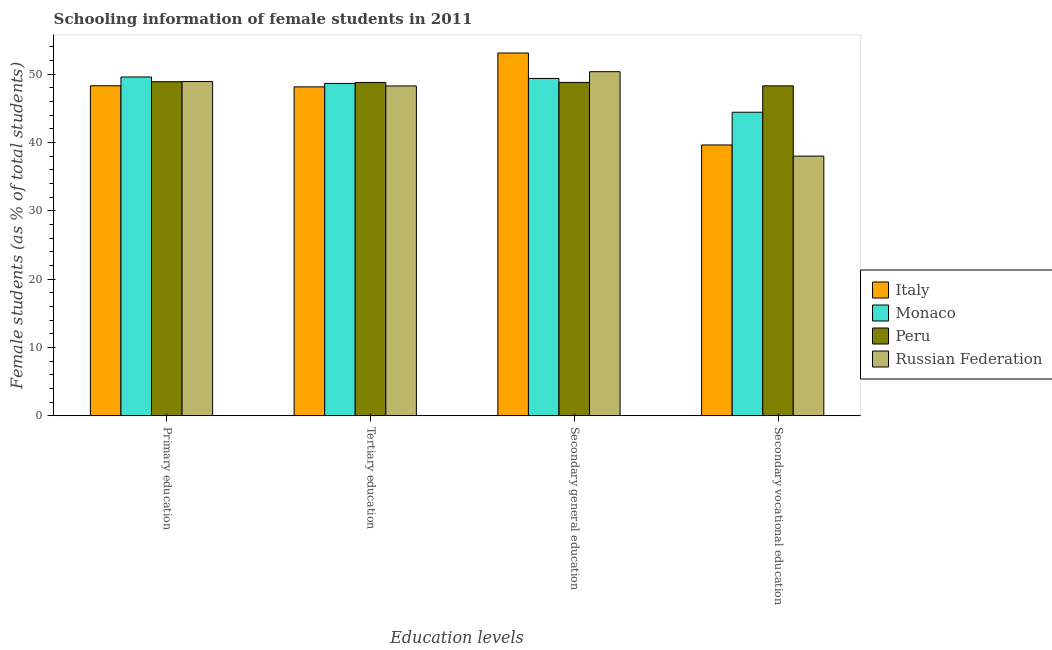How many groups of bars are there?
Provide a short and direct response. 4. Are the number of bars on each tick of the X-axis equal?
Provide a short and direct response. Yes. How many bars are there on the 2nd tick from the right?
Keep it short and to the point. 4. What is the label of the 2nd group of bars from the left?
Your answer should be compact. Tertiary education. What is the percentage of female students in primary education in Italy?
Offer a terse response. 48.32. Across all countries, what is the maximum percentage of female students in secondary vocational education?
Provide a short and direct response. 48.3. Across all countries, what is the minimum percentage of female students in secondary education?
Your answer should be very brief. 48.81. In which country was the percentage of female students in secondary vocational education minimum?
Your answer should be compact. Russian Federation. What is the total percentage of female students in secondary education in the graph?
Keep it short and to the point. 201.68. What is the difference between the percentage of female students in tertiary education in Russian Federation and that in Italy?
Offer a terse response. 0.14. What is the difference between the percentage of female students in tertiary education in Russian Federation and the percentage of female students in secondary vocational education in Monaco?
Provide a short and direct response. 3.84. What is the average percentage of female students in secondary vocational education per country?
Your answer should be very brief. 42.61. What is the difference between the percentage of female students in primary education and percentage of female students in secondary vocational education in Peru?
Your answer should be very brief. 0.61. In how many countries, is the percentage of female students in secondary education greater than 12 %?
Your response must be concise. 4. What is the ratio of the percentage of female students in secondary vocational education in Peru to that in Russian Federation?
Ensure brevity in your answer.  1.27. Is the difference between the percentage of female students in secondary education in Russian Federation and Monaco greater than the difference between the percentage of female students in secondary vocational education in Russian Federation and Monaco?
Offer a very short reply. Yes. What is the difference between the highest and the second highest percentage of female students in secondary vocational education?
Keep it short and to the point. 3.86. What is the difference between the highest and the lowest percentage of female students in secondary education?
Your response must be concise. 4.3. In how many countries, is the percentage of female students in secondary education greater than the average percentage of female students in secondary education taken over all countries?
Provide a succinct answer. 1. Is the sum of the percentage of female students in primary education in Russian Federation and Peru greater than the maximum percentage of female students in secondary vocational education across all countries?
Ensure brevity in your answer.  Yes. What does the 1st bar from the left in Secondary vocational education represents?
Offer a terse response. Italy. What does the 2nd bar from the right in Primary education represents?
Your answer should be very brief. Peru. How many bars are there?
Make the answer very short. 16. Does the graph contain any zero values?
Your answer should be very brief. No. Does the graph contain grids?
Offer a very short reply. No. How are the legend labels stacked?
Offer a terse response. Vertical. What is the title of the graph?
Make the answer very short. Schooling information of female students in 2011. Does "Pacific island small states" appear as one of the legend labels in the graph?
Make the answer very short. No. What is the label or title of the X-axis?
Ensure brevity in your answer.  Education levels. What is the label or title of the Y-axis?
Make the answer very short. Female students (as % of total students). What is the Female students (as % of total students) in Italy in Primary education?
Provide a succinct answer. 48.32. What is the Female students (as % of total students) of Monaco in Primary education?
Your answer should be compact. 49.6. What is the Female students (as % of total students) in Peru in Primary education?
Provide a succinct answer. 48.91. What is the Female students (as % of total students) in Russian Federation in Primary education?
Keep it short and to the point. 48.94. What is the Female students (as % of total students) in Italy in Tertiary education?
Your answer should be very brief. 48.15. What is the Female students (as % of total students) in Monaco in Tertiary education?
Provide a succinct answer. 48.66. What is the Female students (as % of total students) in Peru in Tertiary education?
Your answer should be very brief. 48.8. What is the Female students (as % of total students) in Russian Federation in Tertiary education?
Provide a succinct answer. 48.29. What is the Female students (as % of total students) of Italy in Secondary general education?
Offer a very short reply. 53.11. What is the Female students (as % of total students) in Monaco in Secondary general education?
Your answer should be very brief. 49.39. What is the Female students (as % of total students) of Peru in Secondary general education?
Ensure brevity in your answer.  48.81. What is the Female students (as % of total students) in Russian Federation in Secondary general education?
Your response must be concise. 50.38. What is the Female students (as % of total students) in Italy in Secondary vocational education?
Provide a succinct answer. 39.65. What is the Female students (as % of total students) in Monaco in Secondary vocational education?
Offer a very short reply. 44.44. What is the Female students (as % of total students) in Peru in Secondary vocational education?
Offer a terse response. 48.3. What is the Female students (as % of total students) in Russian Federation in Secondary vocational education?
Your answer should be very brief. 38.02. Across all Education levels, what is the maximum Female students (as % of total students) in Italy?
Your response must be concise. 53.11. Across all Education levels, what is the maximum Female students (as % of total students) of Monaco?
Provide a short and direct response. 49.6. Across all Education levels, what is the maximum Female students (as % of total students) of Peru?
Ensure brevity in your answer.  48.91. Across all Education levels, what is the maximum Female students (as % of total students) in Russian Federation?
Your answer should be very brief. 50.38. Across all Education levels, what is the minimum Female students (as % of total students) in Italy?
Your answer should be compact. 39.65. Across all Education levels, what is the minimum Female students (as % of total students) of Monaco?
Ensure brevity in your answer.  44.44. Across all Education levels, what is the minimum Female students (as % of total students) in Peru?
Make the answer very short. 48.3. Across all Education levels, what is the minimum Female students (as % of total students) of Russian Federation?
Keep it short and to the point. 38.02. What is the total Female students (as % of total students) of Italy in the graph?
Provide a succinct answer. 189.24. What is the total Female students (as % of total students) of Monaco in the graph?
Give a very brief answer. 192.09. What is the total Female students (as % of total students) of Peru in the graph?
Offer a very short reply. 194.83. What is the total Female students (as % of total students) in Russian Federation in the graph?
Offer a very short reply. 185.62. What is the difference between the Female students (as % of total students) in Italy in Primary education and that in Tertiary education?
Provide a succinct answer. 0.17. What is the difference between the Female students (as % of total students) of Monaco in Primary education and that in Tertiary education?
Make the answer very short. 0.94. What is the difference between the Female students (as % of total students) in Peru in Primary education and that in Tertiary education?
Provide a succinct answer. 0.11. What is the difference between the Female students (as % of total students) in Russian Federation in Primary education and that in Tertiary education?
Provide a succinct answer. 0.65. What is the difference between the Female students (as % of total students) of Italy in Primary education and that in Secondary general education?
Give a very brief answer. -4.79. What is the difference between the Female students (as % of total students) in Monaco in Primary education and that in Secondary general education?
Provide a short and direct response. 0.22. What is the difference between the Female students (as % of total students) in Peru in Primary education and that in Secondary general education?
Provide a short and direct response. 0.1. What is the difference between the Female students (as % of total students) of Russian Federation in Primary education and that in Secondary general education?
Provide a succinct answer. -1.44. What is the difference between the Female students (as % of total students) in Italy in Primary education and that in Secondary vocational education?
Your answer should be compact. 8.67. What is the difference between the Female students (as % of total students) in Monaco in Primary education and that in Secondary vocational education?
Provide a succinct answer. 5.16. What is the difference between the Female students (as % of total students) of Peru in Primary education and that in Secondary vocational education?
Your answer should be very brief. 0.61. What is the difference between the Female students (as % of total students) of Russian Federation in Primary education and that in Secondary vocational education?
Give a very brief answer. 10.92. What is the difference between the Female students (as % of total students) of Italy in Tertiary education and that in Secondary general education?
Your response must be concise. -4.96. What is the difference between the Female students (as % of total students) of Monaco in Tertiary education and that in Secondary general education?
Provide a succinct answer. -0.73. What is the difference between the Female students (as % of total students) in Peru in Tertiary education and that in Secondary general education?
Provide a short and direct response. -0.01. What is the difference between the Female students (as % of total students) in Russian Federation in Tertiary education and that in Secondary general education?
Give a very brief answer. -2.09. What is the difference between the Female students (as % of total students) in Italy in Tertiary education and that in Secondary vocational education?
Ensure brevity in your answer.  8.5. What is the difference between the Female students (as % of total students) of Monaco in Tertiary education and that in Secondary vocational education?
Keep it short and to the point. 4.22. What is the difference between the Female students (as % of total students) in Peru in Tertiary education and that in Secondary vocational education?
Give a very brief answer. 0.5. What is the difference between the Female students (as % of total students) in Russian Federation in Tertiary education and that in Secondary vocational education?
Your response must be concise. 10.27. What is the difference between the Female students (as % of total students) of Italy in Secondary general education and that in Secondary vocational education?
Ensure brevity in your answer.  13.46. What is the difference between the Female students (as % of total students) of Monaco in Secondary general education and that in Secondary vocational education?
Offer a very short reply. 4.94. What is the difference between the Female students (as % of total students) of Peru in Secondary general education and that in Secondary vocational education?
Your answer should be compact. 0.51. What is the difference between the Female students (as % of total students) of Russian Federation in Secondary general education and that in Secondary vocational education?
Provide a succinct answer. 12.35. What is the difference between the Female students (as % of total students) in Italy in Primary education and the Female students (as % of total students) in Monaco in Tertiary education?
Your answer should be compact. -0.34. What is the difference between the Female students (as % of total students) of Italy in Primary education and the Female students (as % of total students) of Peru in Tertiary education?
Make the answer very short. -0.48. What is the difference between the Female students (as % of total students) in Italy in Primary education and the Female students (as % of total students) in Russian Federation in Tertiary education?
Keep it short and to the point. 0.03. What is the difference between the Female students (as % of total students) of Monaco in Primary education and the Female students (as % of total students) of Peru in Tertiary education?
Your answer should be compact. 0.8. What is the difference between the Female students (as % of total students) in Monaco in Primary education and the Female students (as % of total students) in Russian Federation in Tertiary education?
Provide a succinct answer. 1.31. What is the difference between the Female students (as % of total students) of Peru in Primary education and the Female students (as % of total students) of Russian Federation in Tertiary education?
Offer a very short reply. 0.62. What is the difference between the Female students (as % of total students) of Italy in Primary education and the Female students (as % of total students) of Monaco in Secondary general education?
Make the answer very short. -1.07. What is the difference between the Female students (as % of total students) of Italy in Primary education and the Female students (as % of total students) of Peru in Secondary general education?
Offer a terse response. -0.49. What is the difference between the Female students (as % of total students) in Italy in Primary education and the Female students (as % of total students) in Russian Federation in Secondary general education?
Ensure brevity in your answer.  -2.06. What is the difference between the Female students (as % of total students) in Monaco in Primary education and the Female students (as % of total students) in Peru in Secondary general education?
Give a very brief answer. 0.79. What is the difference between the Female students (as % of total students) in Monaco in Primary education and the Female students (as % of total students) in Russian Federation in Secondary general education?
Provide a short and direct response. -0.77. What is the difference between the Female students (as % of total students) of Peru in Primary education and the Female students (as % of total students) of Russian Federation in Secondary general education?
Your answer should be compact. -1.46. What is the difference between the Female students (as % of total students) in Italy in Primary education and the Female students (as % of total students) in Monaco in Secondary vocational education?
Make the answer very short. 3.87. What is the difference between the Female students (as % of total students) in Italy in Primary education and the Female students (as % of total students) in Peru in Secondary vocational education?
Offer a very short reply. 0.02. What is the difference between the Female students (as % of total students) in Italy in Primary education and the Female students (as % of total students) in Russian Federation in Secondary vocational education?
Provide a succinct answer. 10.3. What is the difference between the Female students (as % of total students) of Monaco in Primary education and the Female students (as % of total students) of Peru in Secondary vocational education?
Make the answer very short. 1.3. What is the difference between the Female students (as % of total students) in Monaco in Primary education and the Female students (as % of total students) in Russian Federation in Secondary vocational education?
Keep it short and to the point. 11.58. What is the difference between the Female students (as % of total students) of Peru in Primary education and the Female students (as % of total students) of Russian Federation in Secondary vocational education?
Provide a succinct answer. 10.89. What is the difference between the Female students (as % of total students) of Italy in Tertiary education and the Female students (as % of total students) of Monaco in Secondary general education?
Give a very brief answer. -1.23. What is the difference between the Female students (as % of total students) of Italy in Tertiary education and the Female students (as % of total students) of Peru in Secondary general education?
Provide a succinct answer. -0.66. What is the difference between the Female students (as % of total students) in Italy in Tertiary education and the Female students (as % of total students) in Russian Federation in Secondary general education?
Give a very brief answer. -2.22. What is the difference between the Female students (as % of total students) in Monaco in Tertiary education and the Female students (as % of total students) in Peru in Secondary general education?
Your answer should be compact. -0.15. What is the difference between the Female students (as % of total students) in Monaco in Tertiary education and the Female students (as % of total students) in Russian Federation in Secondary general education?
Provide a succinct answer. -1.72. What is the difference between the Female students (as % of total students) in Peru in Tertiary education and the Female students (as % of total students) in Russian Federation in Secondary general education?
Provide a short and direct response. -1.57. What is the difference between the Female students (as % of total students) of Italy in Tertiary education and the Female students (as % of total students) of Monaco in Secondary vocational education?
Ensure brevity in your answer.  3.71. What is the difference between the Female students (as % of total students) of Italy in Tertiary education and the Female students (as % of total students) of Peru in Secondary vocational education?
Offer a very short reply. -0.15. What is the difference between the Female students (as % of total students) in Italy in Tertiary education and the Female students (as % of total students) in Russian Federation in Secondary vocational education?
Your answer should be very brief. 10.13. What is the difference between the Female students (as % of total students) of Monaco in Tertiary education and the Female students (as % of total students) of Peru in Secondary vocational education?
Offer a very short reply. 0.36. What is the difference between the Female students (as % of total students) in Monaco in Tertiary education and the Female students (as % of total students) in Russian Federation in Secondary vocational education?
Your answer should be compact. 10.64. What is the difference between the Female students (as % of total students) of Peru in Tertiary education and the Female students (as % of total students) of Russian Federation in Secondary vocational education?
Provide a short and direct response. 10.78. What is the difference between the Female students (as % of total students) of Italy in Secondary general education and the Female students (as % of total students) of Monaco in Secondary vocational education?
Your response must be concise. 8.67. What is the difference between the Female students (as % of total students) in Italy in Secondary general education and the Female students (as % of total students) in Peru in Secondary vocational education?
Give a very brief answer. 4.81. What is the difference between the Female students (as % of total students) in Italy in Secondary general education and the Female students (as % of total students) in Russian Federation in Secondary vocational education?
Offer a very short reply. 15.09. What is the difference between the Female students (as % of total students) in Monaco in Secondary general education and the Female students (as % of total students) in Peru in Secondary vocational education?
Provide a short and direct response. 1.08. What is the difference between the Female students (as % of total students) of Monaco in Secondary general education and the Female students (as % of total students) of Russian Federation in Secondary vocational education?
Your answer should be compact. 11.37. What is the difference between the Female students (as % of total students) in Peru in Secondary general education and the Female students (as % of total students) in Russian Federation in Secondary vocational education?
Make the answer very short. 10.79. What is the average Female students (as % of total students) of Italy per Education levels?
Keep it short and to the point. 47.31. What is the average Female students (as % of total students) of Monaco per Education levels?
Make the answer very short. 48.02. What is the average Female students (as % of total students) in Peru per Education levels?
Your answer should be very brief. 48.71. What is the average Female students (as % of total students) of Russian Federation per Education levels?
Your answer should be compact. 46.41. What is the difference between the Female students (as % of total students) in Italy and Female students (as % of total students) in Monaco in Primary education?
Your answer should be very brief. -1.28. What is the difference between the Female students (as % of total students) in Italy and Female students (as % of total students) in Peru in Primary education?
Ensure brevity in your answer.  -0.59. What is the difference between the Female students (as % of total students) of Italy and Female students (as % of total students) of Russian Federation in Primary education?
Provide a short and direct response. -0.62. What is the difference between the Female students (as % of total students) in Monaco and Female students (as % of total students) in Peru in Primary education?
Provide a short and direct response. 0.69. What is the difference between the Female students (as % of total students) in Monaco and Female students (as % of total students) in Russian Federation in Primary education?
Your answer should be compact. 0.66. What is the difference between the Female students (as % of total students) of Peru and Female students (as % of total students) of Russian Federation in Primary education?
Keep it short and to the point. -0.03. What is the difference between the Female students (as % of total students) of Italy and Female students (as % of total students) of Monaco in Tertiary education?
Give a very brief answer. -0.51. What is the difference between the Female students (as % of total students) of Italy and Female students (as % of total students) of Peru in Tertiary education?
Offer a terse response. -0.65. What is the difference between the Female students (as % of total students) in Italy and Female students (as % of total students) in Russian Federation in Tertiary education?
Give a very brief answer. -0.14. What is the difference between the Female students (as % of total students) of Monaco and Female students (as % of total students) of Peru in Tertiary education?
Offer a very short reply. -0.14. What is the difference between the Female students (as % of total students) in Monaco and Female students (as % of total students) in Russian Federation in Tertiary education?
Your response must be concise. 0.37. What is the difference between the Female students (as % of total students) of Peru and Female students (as % of total students) of Russian Federation in Tertiary education?
Give a very brief answer. 0.51. What is the difference between the Female students (as % of total students) of Italy and Female students (as % of total students) of Monaco in Secondary general education?
Ensure brevity in your answer.  3.72. What is the difference between the Female students (as % of total students) in Italy and Female students (as % of total students) in Peru in Secondary general education?
Keep it short and to the point. 4.3. What is the difference between the Female students (as % of total students) of Italy and Female students (as % of total students) of Russian Federation in Secondary general education?
Your answer should be very brief. 2.73. What is the difference between the Female students (as % of total students) in Monaco and Female students (as % of total students) in Peru in Secondary general education?
Provide a short and direct response. 0.58. What is the difference between the Female students (as % of total students) in Monaco and Female students (as % of total students) in Russian Federation in Secondary general education?
Provide a succinct answer. -0.99. What is the difference between the Female students (as % of total students) of Peru and Female students (as % of total students) of Russian Federation in Secondary general education?
Give a very brief answer. -1.57. What is the difference between the Female students (as % of total students) in Italy and Female students (as % of total students) in Monaco in Secondary vocational education?
Your answer should be very brief. -4.79. What is the difference between the Female students (as % of total students) in Italy and Female students (as % of total students) in Peru in Secondary vocational education?
Offer a terse response. -8.65. What is the difference between the Female students (as % of total students) in Italy and Female students (as % of total students) in Russian Federation in Secondary vocational education?
Provide a succinct answer. 1.63. What is the difference between the Female students (as % of total students) of Monaco and Female students (as % of total students) of Peru in Secondary vocational education?
Make the answer very short. -3.86. What is the difference between the Female students (as % of total students) of Monaco and Female students (as % of total students) of Russian Federation in Secondary vocational education?
Give a very brief answer. 6.42. What is the difference between the Female students (as % of total students) in Peru and Female students (as % of total students) in Russian Federation in Secondary vocational education?
Your answer should be very brief. 10.28. What is the ratio of the Female students (as % of total students) of Monaco in Primary education to that in Tertiary education?
Make the answer very short. 1.02. What is the ratio of the Female students (as % of total students) of Russian Federation in Primary education to that in Tertiary education?
Your answer should be compact. 1.01. What is the ratio of the Female students (as % of total students) of Italy in Primary education to that in Secondary general education?
Your answer should be very brief. 0.91. What is the ratio of the Female students (as % of total students) of Monaco in Primary education to that in Secondary general education?
Make the answer very short. 1. What is the ratio of the Female students (as % of total students) of Russian Federation in Primary education to that in Secondary general education?
Your answer should be very brief. 0.97. What is the ratio of the Female students (as % of total students) in Italy in Primary education to that in Secondary vocational education?
Your response must be concise. 1.22. What is the ratio of the Female students (as % of total students) of Monaco in Primary education to that in Secondary vocational education?
Offer a very short reply. 1.12. What is the ratio of the Female students (as % of total students) of Peru in Primary education to that in Secondary vocational education?
Your answer should be compact. 1.01. What is the ratio of the Female students (as % of total students) of Russian Federation in Primary education to that in Secondary vocational education?
Provide a succinct answer. 1.29. What is the ratio of the Female students (as % of total students) of Italy in Tertiary education to that in Secondary general education?
Your answer should be compact. 0.91. What is the ratio of the Female students (as % of total students) in Russian Federation in Tertiary education to that in Secondary general education?
Provide a short and direct response. 0.96. What is the ratio of the Female students (as % of total students) in Italy in Tertiary education to that in Secondary vocational education?
Offer a very short reply. 1.21. What is the ratio of the Female students (as % of total students) in Monaco in Tertiary education to that in Secondary vocational education?
Keep it short and to the point. 1.09. What is the ratio of the Female students (as % of total students) of Peru in Tertiary education to that in Secondary vocational education?
Ensure brevity in your answer.  1.01. What is the ratio of the Female students (as % of total students) in Russian Federation in Tertiary education to that in Secondary vocational education?
Offer a terse response. 1.27. What is the ratio of the Female students (as % of total students) of Italy in Secondary general education to that in Secondary vocational education?
Offer a very short reply. 1.34. What is the ratio of the Female students (as % of total students) of Monaco in Secondary general education to that in Secondary vocational education?
Keep it short and to the point. 1.11. What is the ratio of the Female students (as % of total students) of Peru in Secondary general education to that in Secondary vocational education?
Your response must be concise. 1.01. What is the ratio of the Female students (as % of total students) of Russian Federation in Secondary general education to that in Secondary vocational education?
Provide a succinct answer. 1.32. What is the difference between the highest and the second highest Female students (as % of total students) of Italy?
Ensure brevity in your answer.  4.79. What is the difference between the highest and the second highest Female students (as % of total students) in Monaco?
Offer a terse response. 0.22. What is the difference between the highest and the second highest Female students (as % of total students) in Peru?
Your response must be concise. 0.1. What is the difference between the highest and the second highest Female students (as % of total students) in Russian Federation?
Your answer should be compact. 1.44. What is the difference between the highest and the lowest Female students (as % of total students) of Italy?
Your answer should be very brief. 13.46. What is the difference between the highest and the lowest Female students (as % of total students) of Monaco?
Provide a succinct answer. 5.16. What is the difference between the highest and the lowest Female students (as % of total students) of Peru?
Your answer should be very brief. 0.61. What is the difference between the highest and the lowest Female students (as % of total students) in Russian Federation?
Offer a terse response. 12.35. 